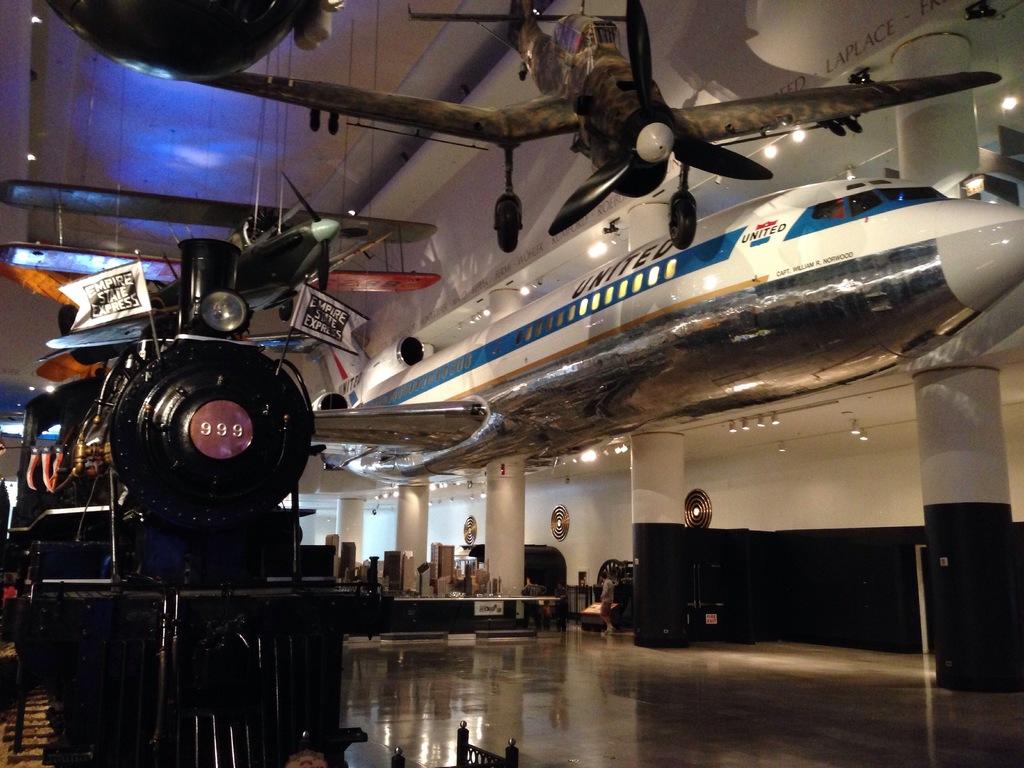What number is on the front of the train?
Offer a terse response. 999. What company owns the airplane?
Offer a terse response. United. 